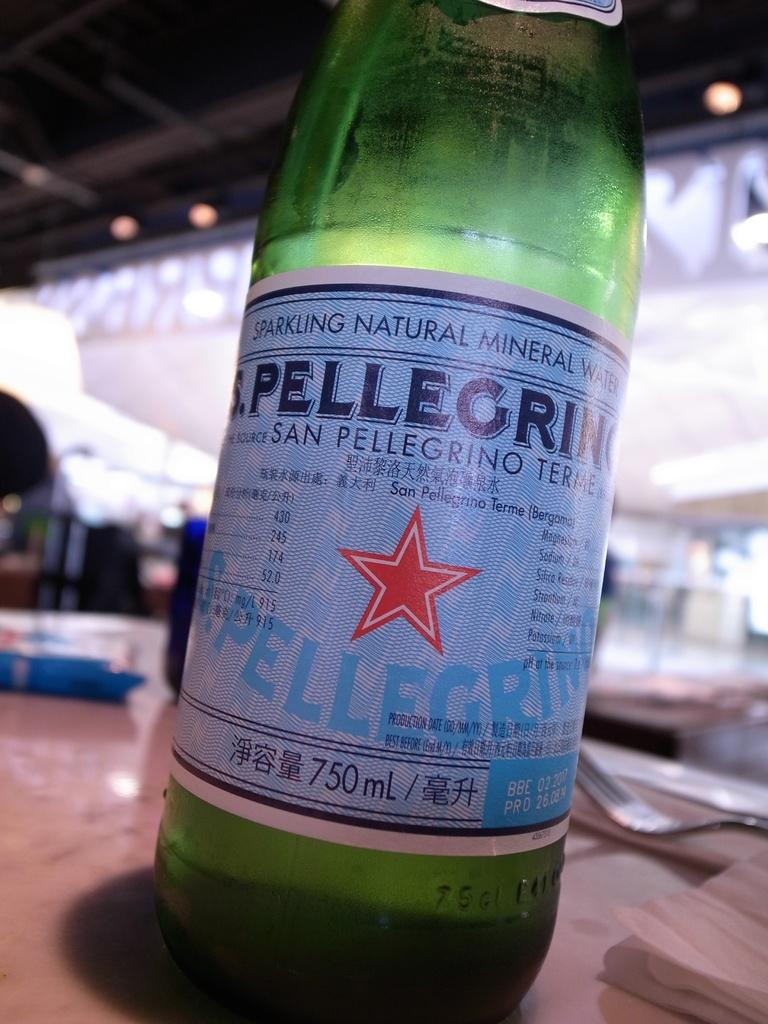<image>
Create a compact narrative representing the image presented. A bottle of sparkling water with the brand San Pellegrino 